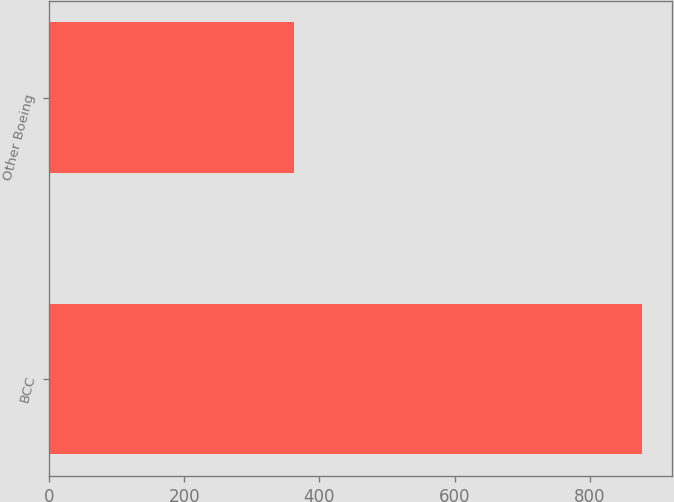Convert chart. <chart><loc_0><loc_0><loc_500><loc_500><bar_chart><fcel>BCC<fcel>Other Boeing<nl><fcel>878<fcel>363<nl></chart> 